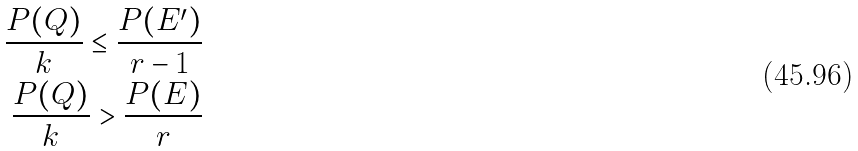<formula> <loc_0><loc_0><loc_500><loc_500>\frac { P ( Q ) } { k } \leq \frac { P ( E ^ { \prime } ) } { r - 1 } \\ \frac { P ( Q ) } { k } > \frac { P ( E ) } { r }</formula> 